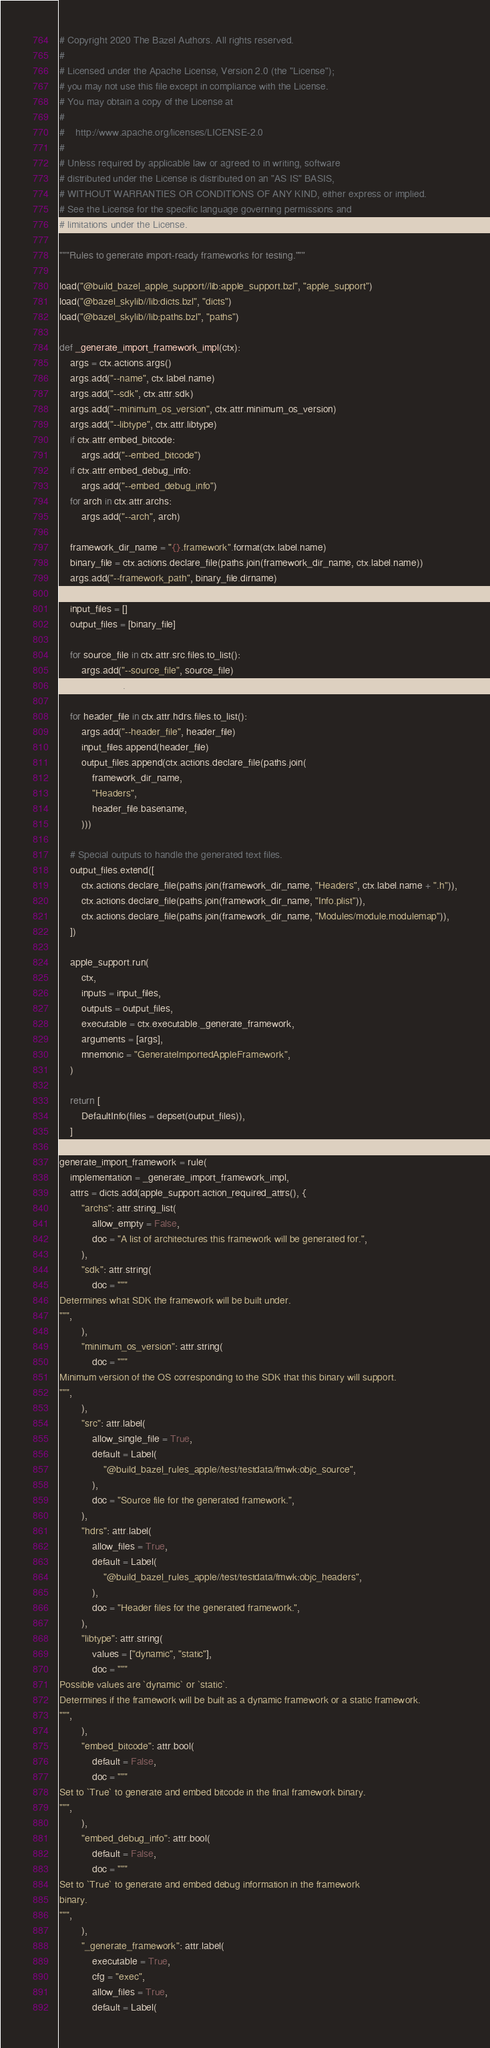<code> <loc_0><loc_0><loc_500><loc_500><_Python_># Copyright 2020 The Bazel Authors. All rights reserved.
#
# Licensed under the Apache License, Version 2.0 (the "License");
# you may not use this file except in compliance with the License.
# You may obtain a copy of the License at
#
#    http://www.apache.org/licenses/LICENSE-2.0
#
# Unless required by applicable law or agreed to in writing, software
# distributed under the License is distributed on an "AS IS" BASIS,
# WITHOUT WARRANTIES OR CONDITIONS OF ANY KIND, either express or implied.
# See the License for the specific language governing permissions and
# limitations under the License.

"""Rules to generate import-ready frameworks for testing."""

load("@build_bazel_apple_support//lib:apple_support.bzl", "apple_support")
load("@bazel_skylib//lib:dicts.bzl", "dicts")
load("@bazel_skylib//lib:paths.bzl", "paths")

def _generate_import_framework_impl(ctx):
    args = ctx.actions.args()
    args.add("--name", ctx.label.name)
    args.add("--sdk", ctx.attr.sdk)
    args.add("--minimum_os_version", ctx.attr.minimum_os_version)
    args.add("--libtype", ctx.attr.libtype)
    if ctx.attr.embed_bitcode:
        args.add("--embed_bitcode")
    if ctx.attr.embed_debug_info:
        args.add("--embed_debug_info")
    for arch in ctx.attr.archs:
        args.add("--arch", arch)

    framework_dir_name = "{}.framework".format(ctx.label.name)
    binary_file = ctx.actions.declare_file(paths.join(framework_dir_name, ctx.label.name))
    args.add("--framework_path", binary_file.dirname)

    input_files = []
    output_files = [binary_file]

    for source_file in ctx.attr.src.files.to_list():
        args.add("--source_file", source_file)
        input_files.append(source_file)

    for header_file in ctx.attr.hdrs.files.to_list():
        args.add("--header_file", header_file)
        input_files.append(header_file)
        output_files.append(ctx.actions.declare_file(paths.join(
            framework_dir_name,
            "Headers",
            header_file.basename,
        )))

    # Special outputs to handle the generated text files.
    output_files.extend([
        ctx.actions.declare_file(paths.join(framework_dir_name, "Headers", ctx.label.name + ".h")),
        ctx.actions.declare_file(paths.join(framework_dir_name, "Info.plist")),
        ctx.actions.declare_file(paths.join(framework_dir_name, "Modules/module.modulemap")),
    ])

    apple_support.run(
        ctx,
        inputs = input_files,
        outputs = output_files,
        executable = ctx.executable._generate_framework,
        arguments = [args],
        mnemonic = "GenerateImportedAppleFramework",
    )

    return [
        DefaultInfo(files = depset(output_files)),
    ]

generate_import_framework = rule(
    implementation = _generate_import_framework_impl,
    attrs = dicts.add(apple_support.action_required_attrs(), {
        "archs": attr.string_list(
            allow_empty = False,
            doc = "A list of architectures this framework will be generated for.",
        ),
        "sdk": attr.string(
            doc = """
Determines what SDK the framework will be built under.
""",
        ),
        "minimum_os_version": attr.string(
            doc = """
Minimum version of the OS corresponding to the SDK that this binary will support.
""",
        ),
        "src": attr.label(
            allow_single_file = True,
            default = Label(
                "@build_bazel_rules_apple//test/testdata/fmwk:objc_source",
            ),
            doc = "Source file for the generated framework.",
        ),
        "hdrs": attr.label(
            allow_files = True,
            default = Label(
                "@build_bazel_rules_apple//test/testdata/fmwk:objc_headers",
            ),
            doc = "Header files for the generated framework.",
        ),
        "libtype": attr.string(
            values = ["dynamic", "static"],
            doc = """
Possible values are `dynamic` or `static`.
Determines if the framework will be built as a dynamic framework or a static framework.
""",
        ),
        "embed_bitcode": attr.bool(
            default = False,
            doc = """
Set to `True` to generate and embed bitcode in the final framework binary.
""",
        ),
        "embed_debug_info": attr.bool(
            default = False,
            doc = """
Set to `True` to generate and embed debug information in the framework
binary.
""",
        ),
        "_generate_framework": attr.label(
            executable = True,
            cfg = "exec",
            allow_files = True,
            default = Label(</code> 